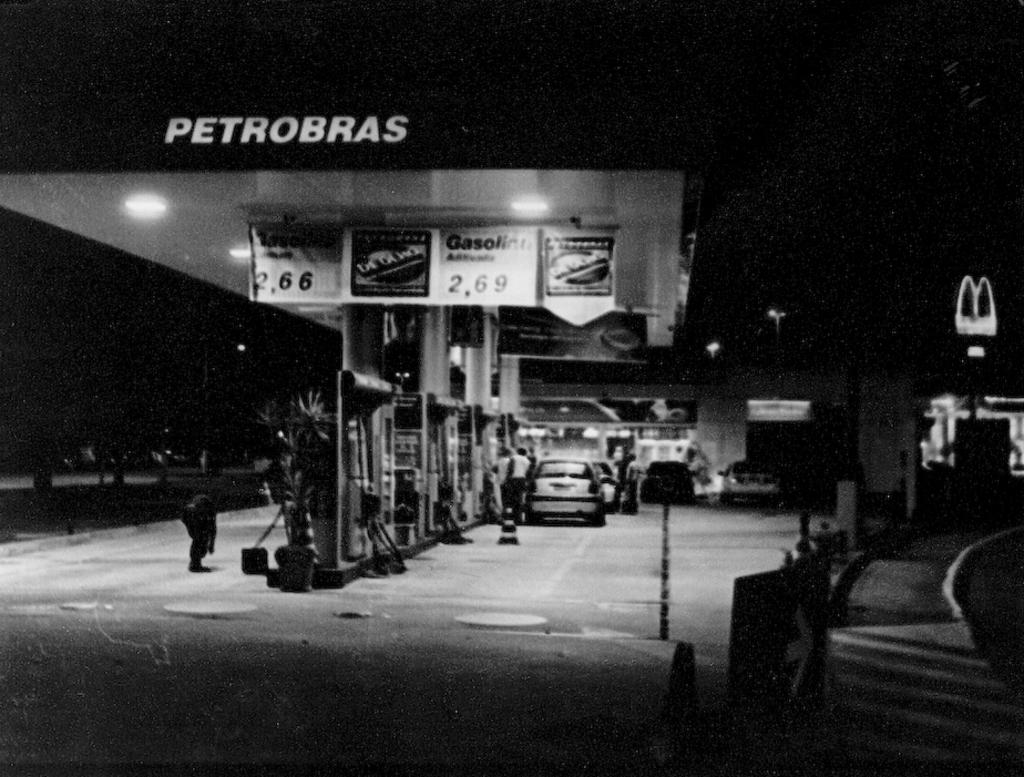What type of vehicles can be seen in the image? There are cars in the image. What else is present on the ground in the image besides the cars? There are persons on the ground in the image. What type of vegetation is visible in the image? There are plants in the image. What type of decorations are present in the image? There are banners in the image. What type of illumination is visible in the image? There are lights in the image. How would you describe the overall lighting condition in the image? The background of the image is dark. What type of teeth can be seen in the image? There are no teeth visible in the image; it features cars, persons, plants, banners, lights, and a dark background. How do the cars form a line in the image? The cars are not forming a line in the image; they are simply parked or driving. 